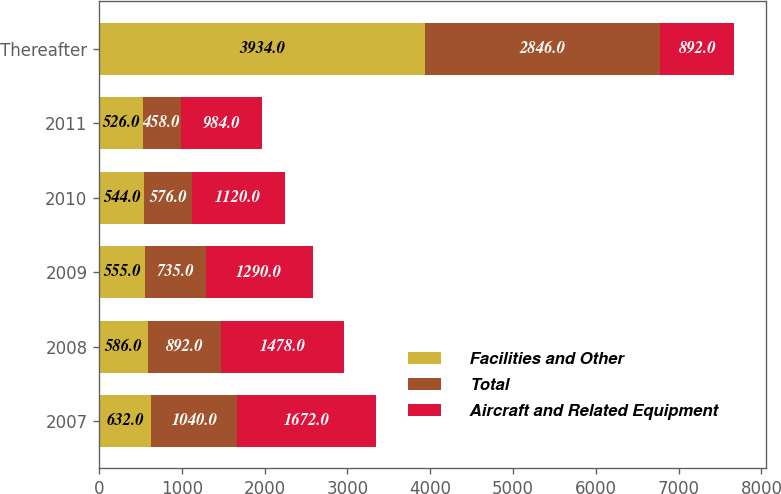Convert chart to OTSL. <chart><loc_0><loc_0><loc_500><loc_500><stacked_bar_chart><ecel><fcel>2007<fcel>2008<fcel>2009<fcel>2010<fcel>2011<fcel>Thereafter<nl><fcel>Facilities and Other<fcel>632<fcel>586<fcel>555<fcel>544<fcel>526<fcel>3934<nl><fcel>Total<fcel>1040<fcel>892<fcel>735<fcel>576<fcel>458<fcel>2846<nl><fcel>Aircraft and Related Equipment<fcel>1672<fcel>1478<fcel>1290<fcel>1120<fcel>984<fcel>892<nl></chart> 